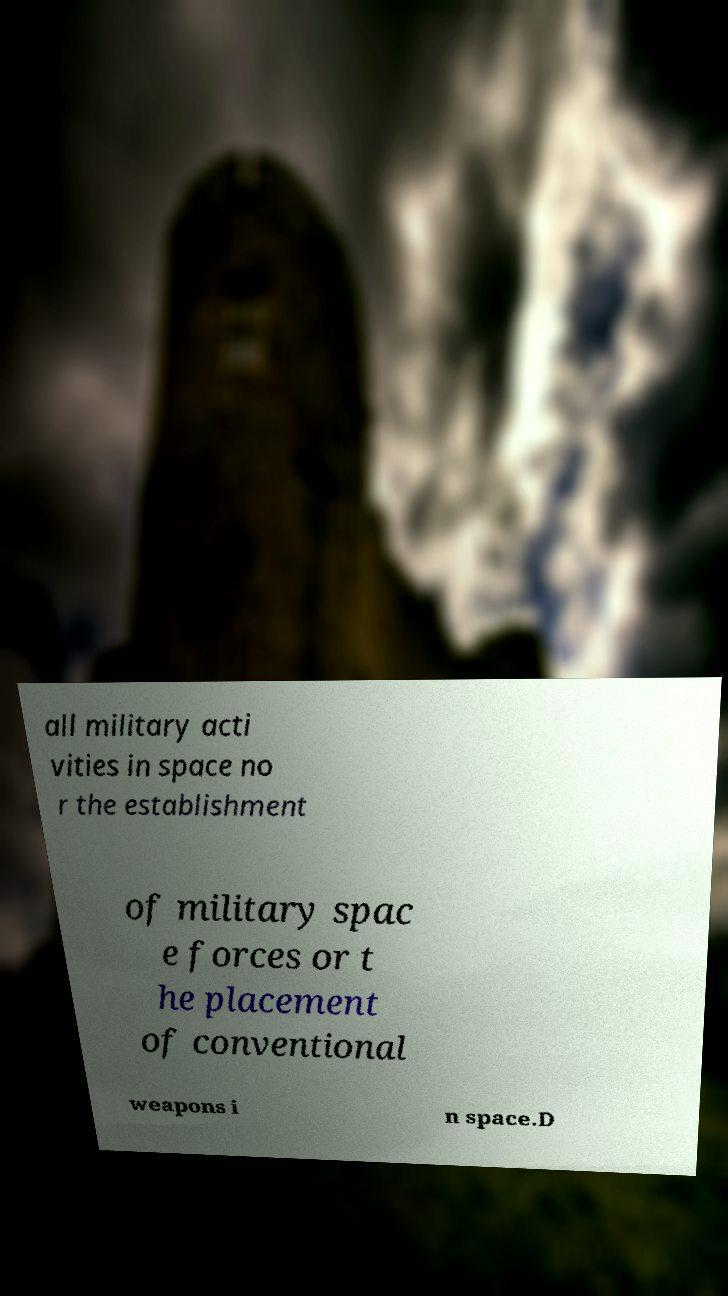What messages or text are displayed in this image? I need them in a readable, typed format. all military acti vities in space no r the establishment of military spac e forces or t he placement of conventional weapons i n space.D 